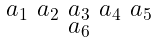<formula> <loc_0><loc_0><loc_500><loc_500>\begin{smallmatrix} a _ { 1 } & a _ { 2 } & a _ { 3 } & a _ { 4 } & a _ { 5 } \\ & & a _ { 6 } & & \end{smallmatrix}</formula> 